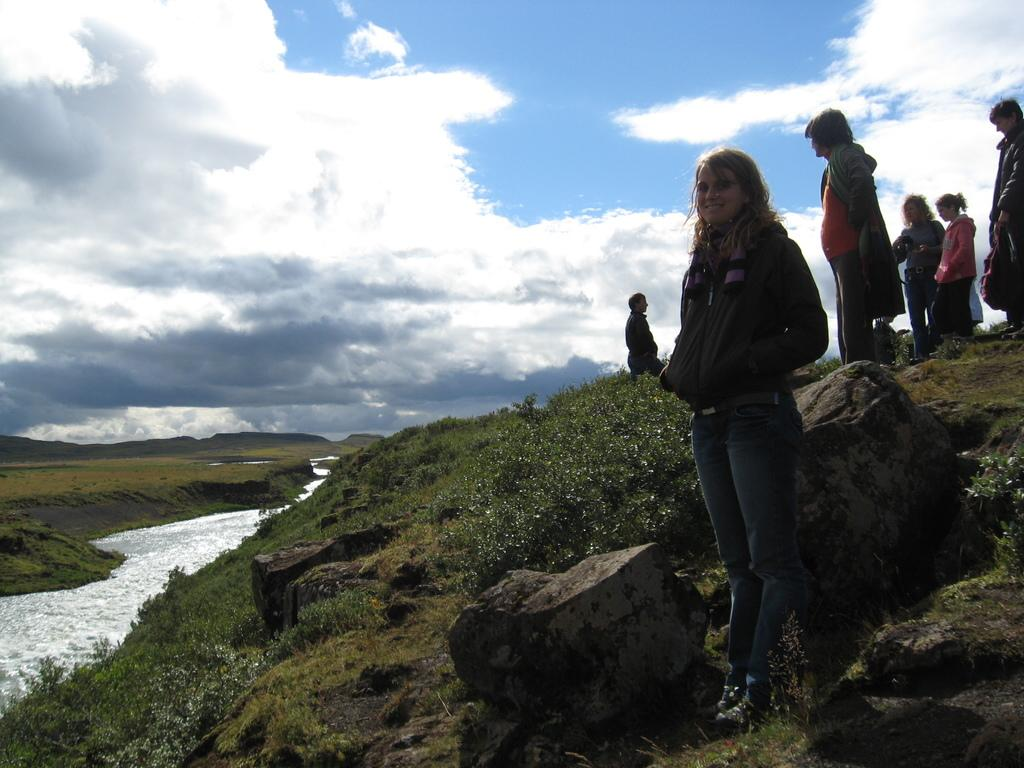What is one of the natural elements present in the image? There is water in the image. What type of vegetation can be seen in the image? There is grass and plants in the image. What type of terrain is visible in the image? There are rocks in the image. Are there any human subjects in the image? Yes, there are people in the image. What is visible at the top of the image? The sky is visible at the top of the image. Where is the duck sitting on the quilt in the image? There is no duck or quilt present in the image. What type of faucet can be seen in the image? There is no faucet present in the image. 